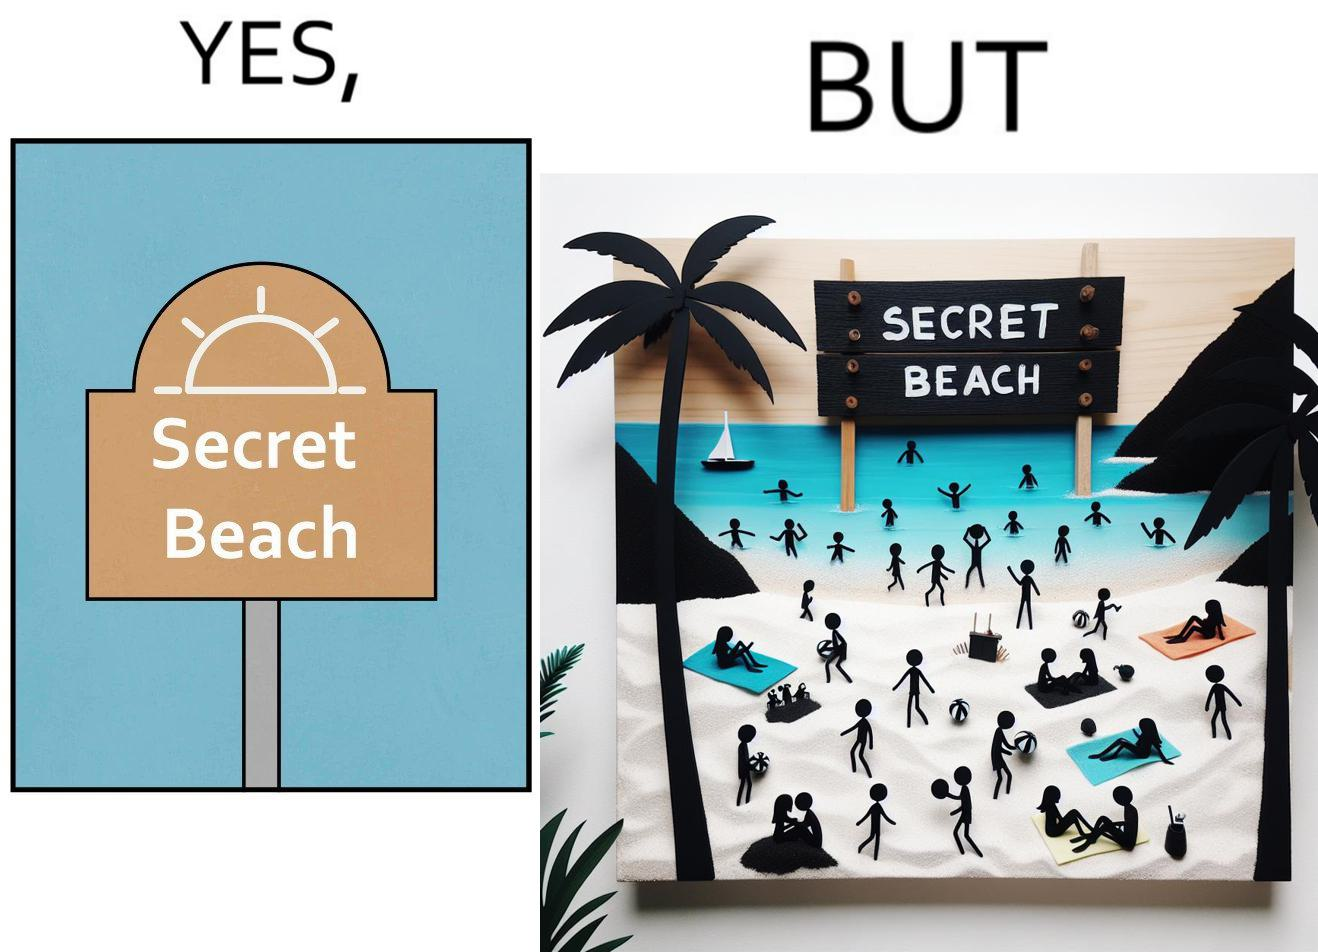Provide a description of this image. The image is ironical, as people can be seen in the beach, and is clearly not a secret, while the board at the entrance has "Secret Beach" written on it. 